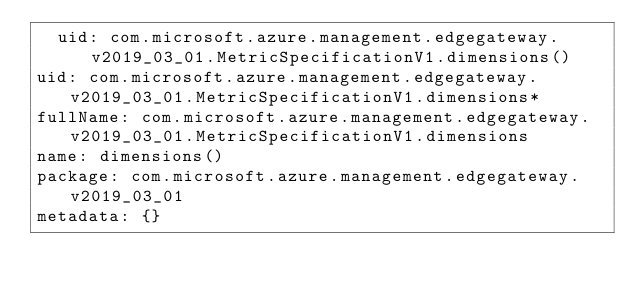<code> <loc_0><loc_0><loc_500><loc_500><_YAML_>  uid: com.microsoft.azure.management.edgegateway.v2019_03_01.MetricSpecificationV1.dimensions()
uid: com.microsoft.azure.management.edgegateway.v2019_03_01.MetricSpecificationV1.dimensions*
fullName: com.microsoft.azure.management.edgegateway.v2019_03_01.MetricSpecificationV1.dimensions
name: dimensions()
package: com.microsoft.azure.management.edgegateway.v2019_03_01
metadata: {}
</code> 